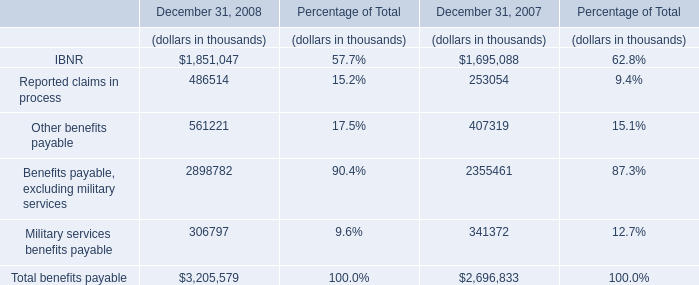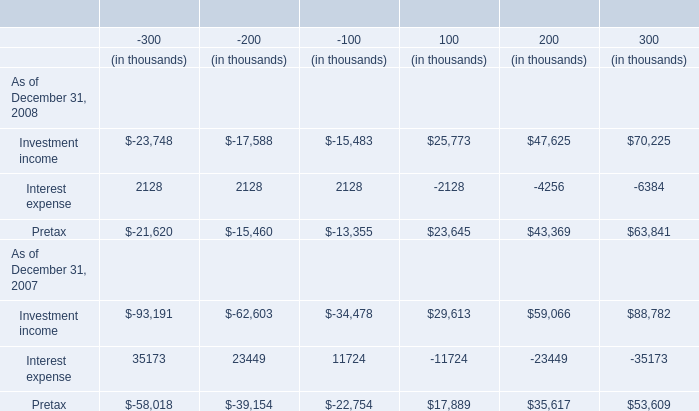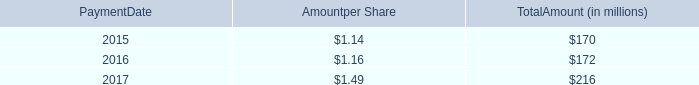what was the number of shares of stockholders of record on december 29 , 2017 in millions 
Computations: (55 / 0.40)
Answer: 137.5. 